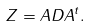Convert formula to latex. <formula><loc_0><loc_0><loc_500><loc_500>Z = A D A ^ { t } .</formula> 